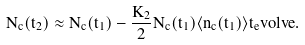<formula> <loc_0><loc_0><loc_500><loc_500>N _ { c } ( t _ { 2 } ) \approx N _ { c } ( t _ { 1 } ) - \frac { K _ { 2 } } { 2 } N _ { c } ( t _ { 1 } ) \langle n _ { c } ( t _ { 1 } ) \rangle t _ { e } v o l v e .</formula> 